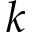Convert formula to latex. <formula><loc_0><loc_0><loc_500><loc_500>k</formula> 